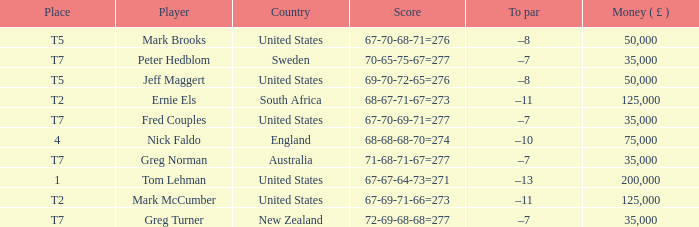What is To par, when Country is "United States", when Money ( £ ) is greater than 125,000, and when Score is "67-70-68-71=276"? None. 